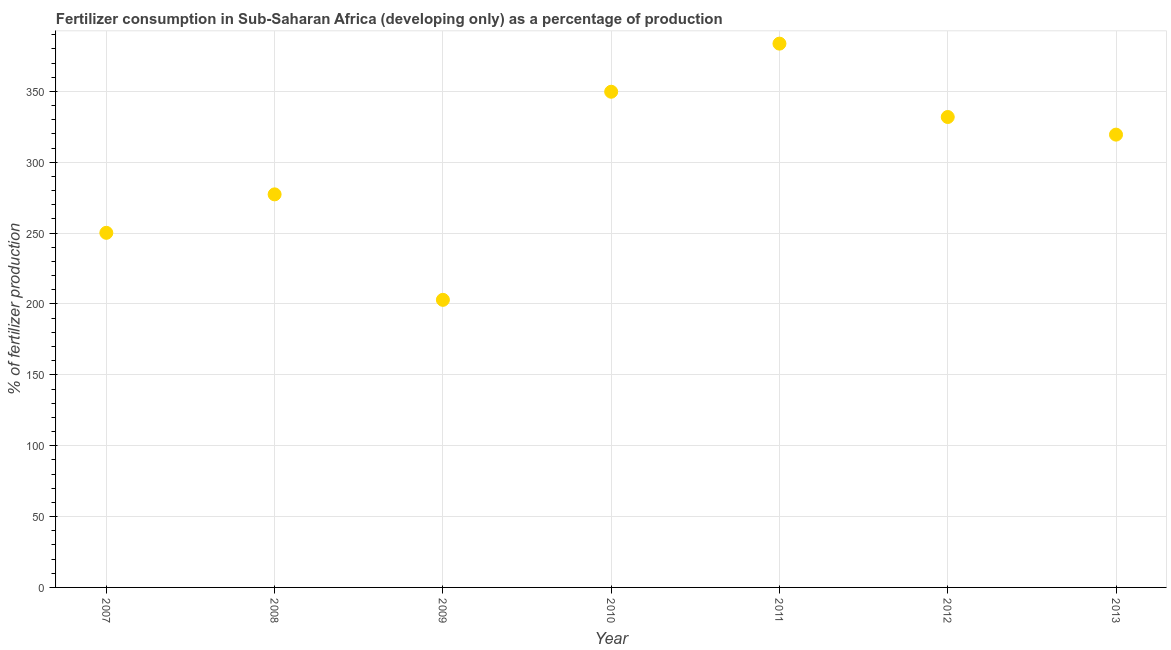What is the amount of fertilizer consumption in 2008?
Offer a very short reply. 277.33. Across all years, what is the maximum amount of fertilizer consumption?
Provide a succinct answer. 383.68. Across all years, what is the minimum amount of fertilizer consumption?
Keep it short and to the point. 202.91. In which year was the amount of fertilizer consumption maximum?
Give a very brief answer. 2011. In which year was the amount of fertilizer consumption minimum?
Provide a short and direct response. 2009. What is the sum of the amount of fertilizer consumption?
Offer a very short reply. 2115.24. What is the difference between the amount of fertilizer consumption in 2012 and 2013?
Give a very brief answer. 12.43. What is the average amount of fertilizer consumption per year?
Ensure brevity in your answer.  302.18. What is the median amount of fertilizer consumption?
Ensure brevity in your answer.  319.48. In how many years, is the amount of fertilizer consumption greater than 120 %?
Your response must be concise. 7. What is the ratio of the amount of fertilizer consumption in 2012 to that in 2013?
Give a very brief answer. 1.04. What is the difference between the highest and the second highest amount of fertilizer consumption?
Provide a succinct answer. 33.94. Is the sum of the amount of fertilizer consumption in 2010 and 2011 greater than the maximum amount of fertilizer consumption across all years?
Keep it short and to the point. Yes. What is the difference between the highest and the lowest amount of fertilizer consumption?
Offer a terse response. 180.77. In how many years, is the amount of fertilizer consumption greater than the average amount of fertilizer consumption taken over all years?
Offer a very short reply. 4. How many dotlines are there?
Your answer should be very brief. 1. How many years are there in the graph?
Ensure brevity in your answer.  7. Are the values on the major ticks of Y-axis written in scientific E-notation?
Your response must be concise. No. Does the graph contain any zero values?
Keep it short and to the point. No. What is the title of the graph?
Offer a very short reply. Fertilizer consumption in Sub-Saharan Africa (developing only) as a percentage of production. What is the label or title of the Y-axis?
Provide a succinct answer. % of fertilizer production. What is the % of fertilizer production in 2007?
Give a very brief answer. 250.2. What is the % of fertilizer production in 2008?
Offer a very short reply. 277.33. What is the % of fertilizer production in 2009?
Your answer should be compact. 202.91. What is the % of fertilizer production in 2010?
Your response must be concise. 349.74. What is the % of fertilizer production in 2011?
Provide a succinct answer. 383.68. What is the % of fertilizer production in 2012?
Keep it short and to the point. 331.91. What is the % of fertilizer production in 2013?
Keep it short and to the point. 319.48. What is the difference between the % of fertilizer production in 2007 and 2008?
Your answer should be compact. -27.13. What is the difference between the % of fertilizer production in 2007 and 2009?
Your answer should be very brief. 47.29. What is the difference between the % of fertilizer production in 2007 and 2010?
Your answer should be compact. -99.54. What is the difference between the % of fertilizer production in 2007 and 2011?
Offer a terse response. -133.48. What is the difference between the % of fertilizer production in 2007 and 2012?
Ensure brevity in your answer.  -81.71. What is the difference between the % of fertilizer production in 2007 and 2013?
Your answer should be very brief. -69.28. What is the difference between the % of fertilizer production in 2008 and 2009?
Your answer should be very brief. 74.42. What is the difference between the % of fertilizer production in 2008 and 2010?
Provide a short and direct response. -72.41. What is the difference between the % of fertilizer production in 2008 and 2011?
Offer a terse response. -106.35. What is the difference between the % of fertilizer production in 2008 and 2012?
Offer a terse response. -54.58. What is the difference between the % of fertilizer production in 2008 and 2013?
Your response must be concise. -42.15. What is the difference between the % of fertilizer production in 2009 and 2010?
Provide a short and direct response. -146.83. What is the difference between the % of fertilizer production in 2009 and 2011?
Keep it short and to the point. -180.77. What is the difference between the % of fertilizer production in 2009 and 2012?
Make the answer very short. -129. What is the difference between the % of fertilizer production in 2009 and 2013?
Make the answer very short. -116.57. What is the difference between the % of fertilizer production in 2010 and 2011?
Ensure brevity in your answer.  -33.94. What is the difference between the % of fertilizer production in 2010 and 2012?
Provide a short and direct response. 17.83. What is the difference between the % of fertilizer production in 2010 and 2013?
Provide a succinct answer. 30.26. What is the difference between the % of fertilizer production in 2011 and 2012?
Your answer should be compact. 51.77. What is the difference between the % of fertilizer production in 2011 and 2013?
Your answer should be compact. 64.2. What is the difference between the % of fertilizer production in 2012 and 2013?
Provide a succinct answer. 12.43. What is the ratio of the % of fertilizer production in 2007 to that in 2008?
Offer a terse response. 0.9. What is the ratio of the % of fertilizer production in 2007 to that in 2009?
Provide a succinct answer. 1.23. What is the ratio of the % of fertilizer production in 2007 to that in 2010?
Make the answer very short. 0.71. What is the ratio of the % of fertilizer production in 2007 to that in 2011?
Your answer should be compact. 0.65. What is the ratio of the % of fertilizer production in 2007 to that in 2012?
Keep it short and to the point. 0.75. What is the ratio of the % of fertilizer production in 2007 to that in 2013?
Provide a short and direct response. 0.78. What is the ratio of the % of fertilizer production in 2008 to that in 2009?
Your answer should be compact. 1.37. What is the ratio of the % of fertilizer production in 2008 to that in 2010?
Provide a succinct answer. 0.79. What is the ratio of the % of fertilizer production in 2008 to that in 2011?
Your response must be concise. 0.72. What is the ratio of the % of fertilizer production in 2008 to that in 2012?
Give a very brief answer. 0.84. What is the ratio of the % of fertilizer production in 2008 to that in 2013?
Ensure brevity in your answer.  0.87. What is the ratio of the % of fertilizer production in 2009 to that in 2010?
Your response must be concise. 0.58. What is the ratio of the % of fertilizer production in 2009 to that in 2011?
Give a very brief answer. 0.53. What is the ratio of the % of fertilizer production in 2009 to that in 2012?
Provide a short and direct response. 0.61. What is the ratio of the % of fertilizer production in 2009 to that in 2013?
Make the answer very short. 0.64. What is the ratio of the % of fertilizer production in 2010 to that in 2011?
Your answer should be compact. 0.91. What is the ratio of the % of fertilizer production in 2010 to that in 2012?
Keep it short and to the point. 1.05. What is the ratio of the % of fertilizer production in 2010 to that in 2013?
Provide a succinct answer. 1.09. What is the ratio of the % of fertilizer production in 2011 to that in 2012?
Give a very brief answer. 1.16. What is the ratio of the % of fertilizer production in 2011 to that in 2013?
Your answer should be very brief. 1.2. What is the ratio of the % of fertilizer production in 2012 to that in 2013?
Offer a very short reply. 1.04. 